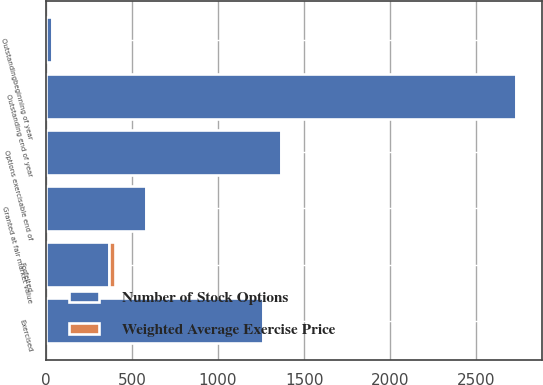<chart> <loc_0><loc_0><loc_500><loc_500><stacked_bar_chart><ecel><fcel>Outstandingbeginning of year<fcel>Granted at fair market value<fcel>Exercised<fcel>Forfeited<fcel>Outstanding end of year<fcel>Options exercisable end of<nl><fcel>Number of Stock Options<fcel>35.55<fcel>579<fcel>1262<fcel>367<fcel>2732<fcel>1366<nl><fcel>Weighted Average Exercise Price<fcel>12.71<fcel>15.41<fcel>5.53<fcel>35.55<fcel>12.98<fcel>7.7<nl></chart> 